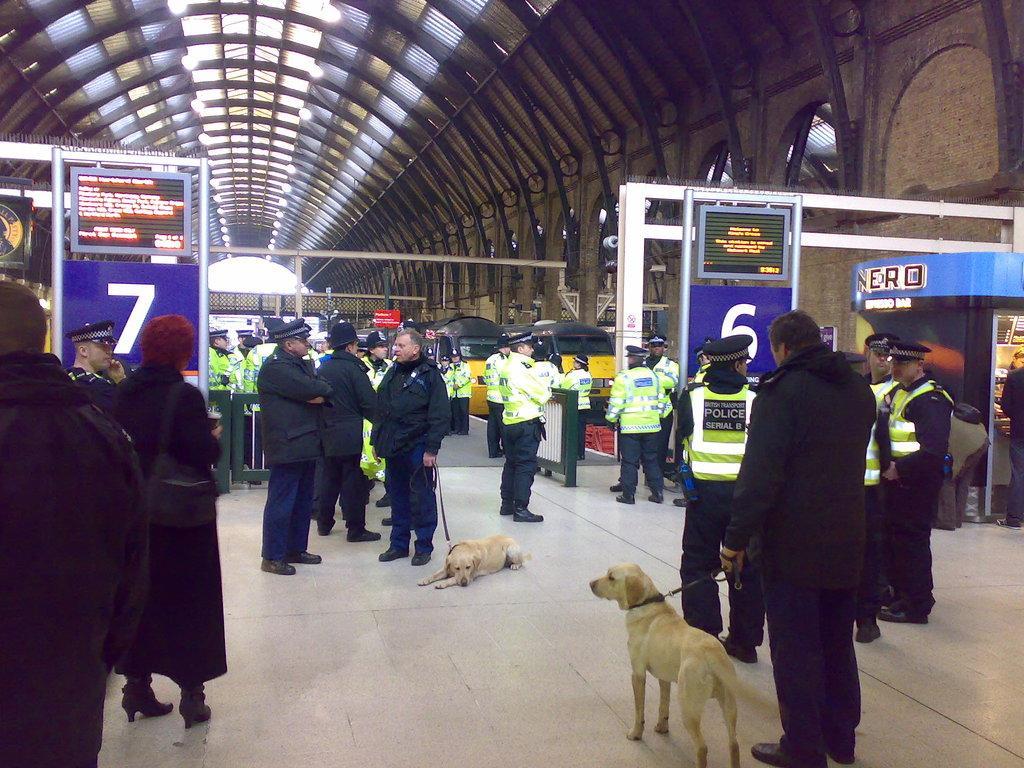How would you summarize this image in a sentence or two? In this image we can see many people. Some are wearing caps. Two persons are holding belts of dogs. There are banners. On the banners there are numbers and some text. On the ceiling there are lights. Also there are arches. 